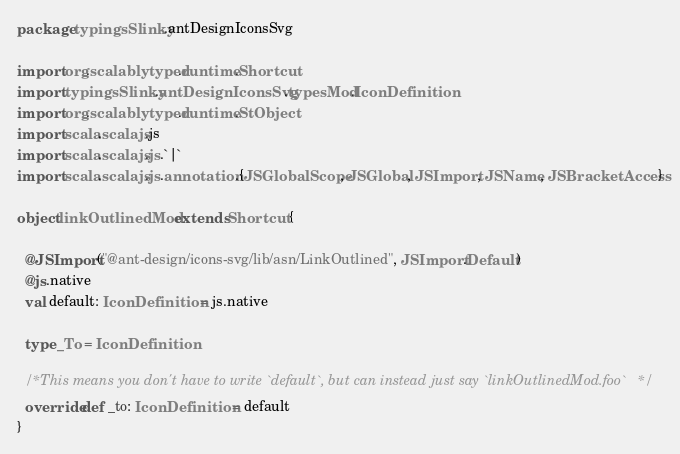Convert code to text. <code><loc_0><loc_0><loc_500><loc_500><_Scala_>package typingsSlinky.antDesignIconsSvg

import org.scalablytyped.runtime.Shortcut
import typingsSlinky.antDesignIconsSvg.typesMod.IconDefinition
import org.scalablytyped.runtime.StObject
import scala.scalajs.js
import scala.scalajs.js.`|`
import scala.scalajs.js.annotation.{JSGlobalScope, JSGlobal, JSImport, JSName, JSBracketAccess}

object linkOutlinedMod extends Shortcut {
  
  @JSImport("@ant-design/icons-svg/lib/asn/LinkOutlined", JSImport.Default)
  @js.native
  val default: IconDefinition = js.native
  
  type _To = IconDefinition
  
  /* This means you don't have to write `default`, but can instead just say `linkOutlinedMod.foo` */
  override def _to: IconDefinition = default
}
</code> 